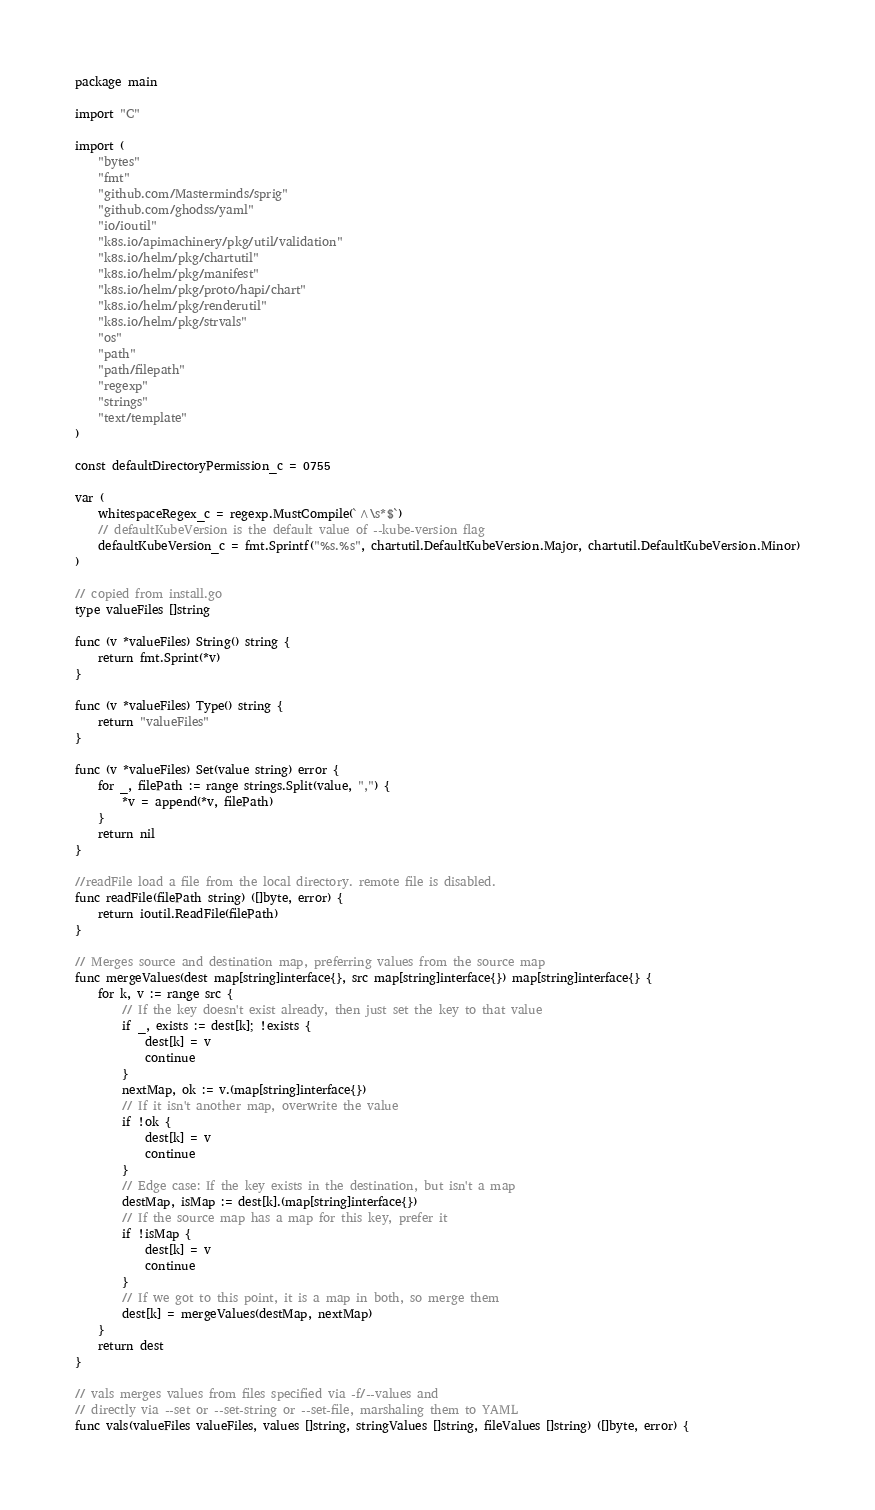<code> <loc_0><loc_0><loc_500><loc_500><_Go_>package main

import "C"

import (
	"bytes"
	"fmt"
	"github.com/Masterminds/sprig"
	"github.com/ghodss/yaml"
	"io/ioutil"
	"k8s.io/apimachinery/pkg/util/validation"
	"k8s.io/helm/pkg/chartutil"
	"k8s.io/helm/pkg/manifest"
	"k8s.io/helm/pkg/proto/hapi/chart"
	"k8s.io/helm/pkg/renderutil"
	"k8s.io/helm/pkg/strvals"
	"os"
	"path"
	"path/filepath"
	"regexp"
	"strings"
	"text/template"
)

const defaultDirectoryPermission_c = 0755

var (
	whitespaceRegex_c = regexp.MustCompile(`^\s*$`)
	// defaultKubeVersion is the default value of --kube-version flag
	defaultKubeVersion_c = fmt.Sprintf("%s.%s", chartutil.DefaultKubeVersion.Major, chartutil.DefaultKubeVersion.Minor)
)

// copied from install.go
type valueFiles []string

func (v *valueFiles) String() string {
	return fmt.Sprint(*v)
}

func (v *valueFiles) Type() string {
	return "valueFiles"
}

func (v *valueFiles) Set(value string) error {
	for _, filePath := range strings.Split(value, ",") {
		*v = append(*v, filePath)
	}
	return nil
}

//readFile load a file from the local directory. remote file is disabled.
func readFile(filePath string) ([]byte, error) {
	return ioutil.ReadFile(filePath)
}

// Merges source and destination map, preferring values from the source map
func mergeValues(dest map[string]interface{}, src map[string]interface{}) map[string]interface{} {
	for k, v := range src {
		// If the key doesn't exist already, then just set the key to that value
		if _, exists := dest[k]; !exists {
			dest[k] = v
			continue
		}
		nextMap, ok := v.(map[string]interface{})
		// If it isn't another map, overwrite the value
		if !ok {
			dest[k] = v
			continue
		}
		// Edge case: If the key exists in the destination, but isn't a map
		destMap, isMap := dest[k].(map[string]interface{})
		// If the source map has a map for this key, prefer it
		if !isMap {
			dest[k] = v
			continue
		}
		// If we got to this point, it is a map in both, so merge them
		dest[k] = mergeValues(destMap, nextMap)
	}
	return dest
}

// vals merges values from files specified via -f/--values and
// directly via --set or --set-string or --set-file, marshaling them to YAML
func vals(valueFiles valueFiles, values []string, stringValues []string, fileValues []string) ([]byte, error) {</code> 